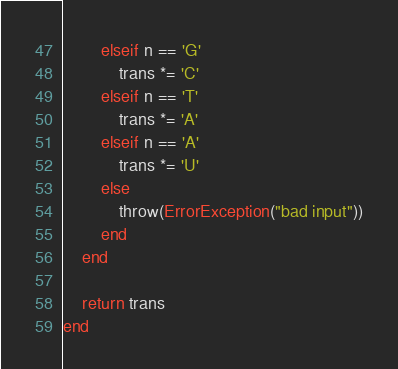Convert code to text. <code><loc_0><loc_0><loc_500><loc_500><_Julia_>        elseif n == 'G'
            trans *= 'C'
        elseif n == 'T'
            trans *= 'A'
        elseif n == 'A'
            trans *= 'U'
        else
            throw(ErrorException("bad input"))
        end
    end

    return trans
end

</code> 